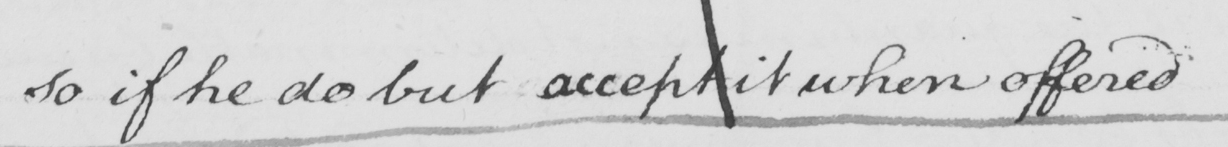What is written in this line of handwriting? So if he do but accept it when offered 